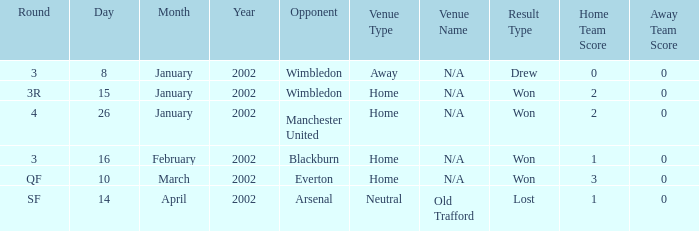What is the Opponent with a Round with 3, and a Venue of home? Blackburn. I'm looking to parse the entire table for insights. Could you assist me with that? {'header': ['Round', 'Day', 'Month', 'Year', 'Opponent', 'Venue Type', 'Venue Name', 'Result Type', 'Home Team Score', 'Away Team Score'], 'rows': [['3', '8', 'January', '2002', 'Wimbledon', 'Away', 'N/A', 'Drew', '0', '0'], ['3R', '15', 'January', '2002', 'Wimbledon', 'Home', 'N/A', 'Won', '2', '0'], ['4', '26', 'January', '2002', 'Manchester United', 'Home', 'N/A', 'Won', '2', '0'], ['3', '16', 'February', '2002', 'Blackburn', 'Home', 'N/A', 'Won', '1', '0'], ['QF', '10', 'March', '2002', 'Everton', 'Home', 'N/A', 'Won', '3', '0'], ['SF', '14', 'April', '2002', 'Arsenal', 'Neutral', 'Old Trafford', 'Lost', '1', '0']]} 